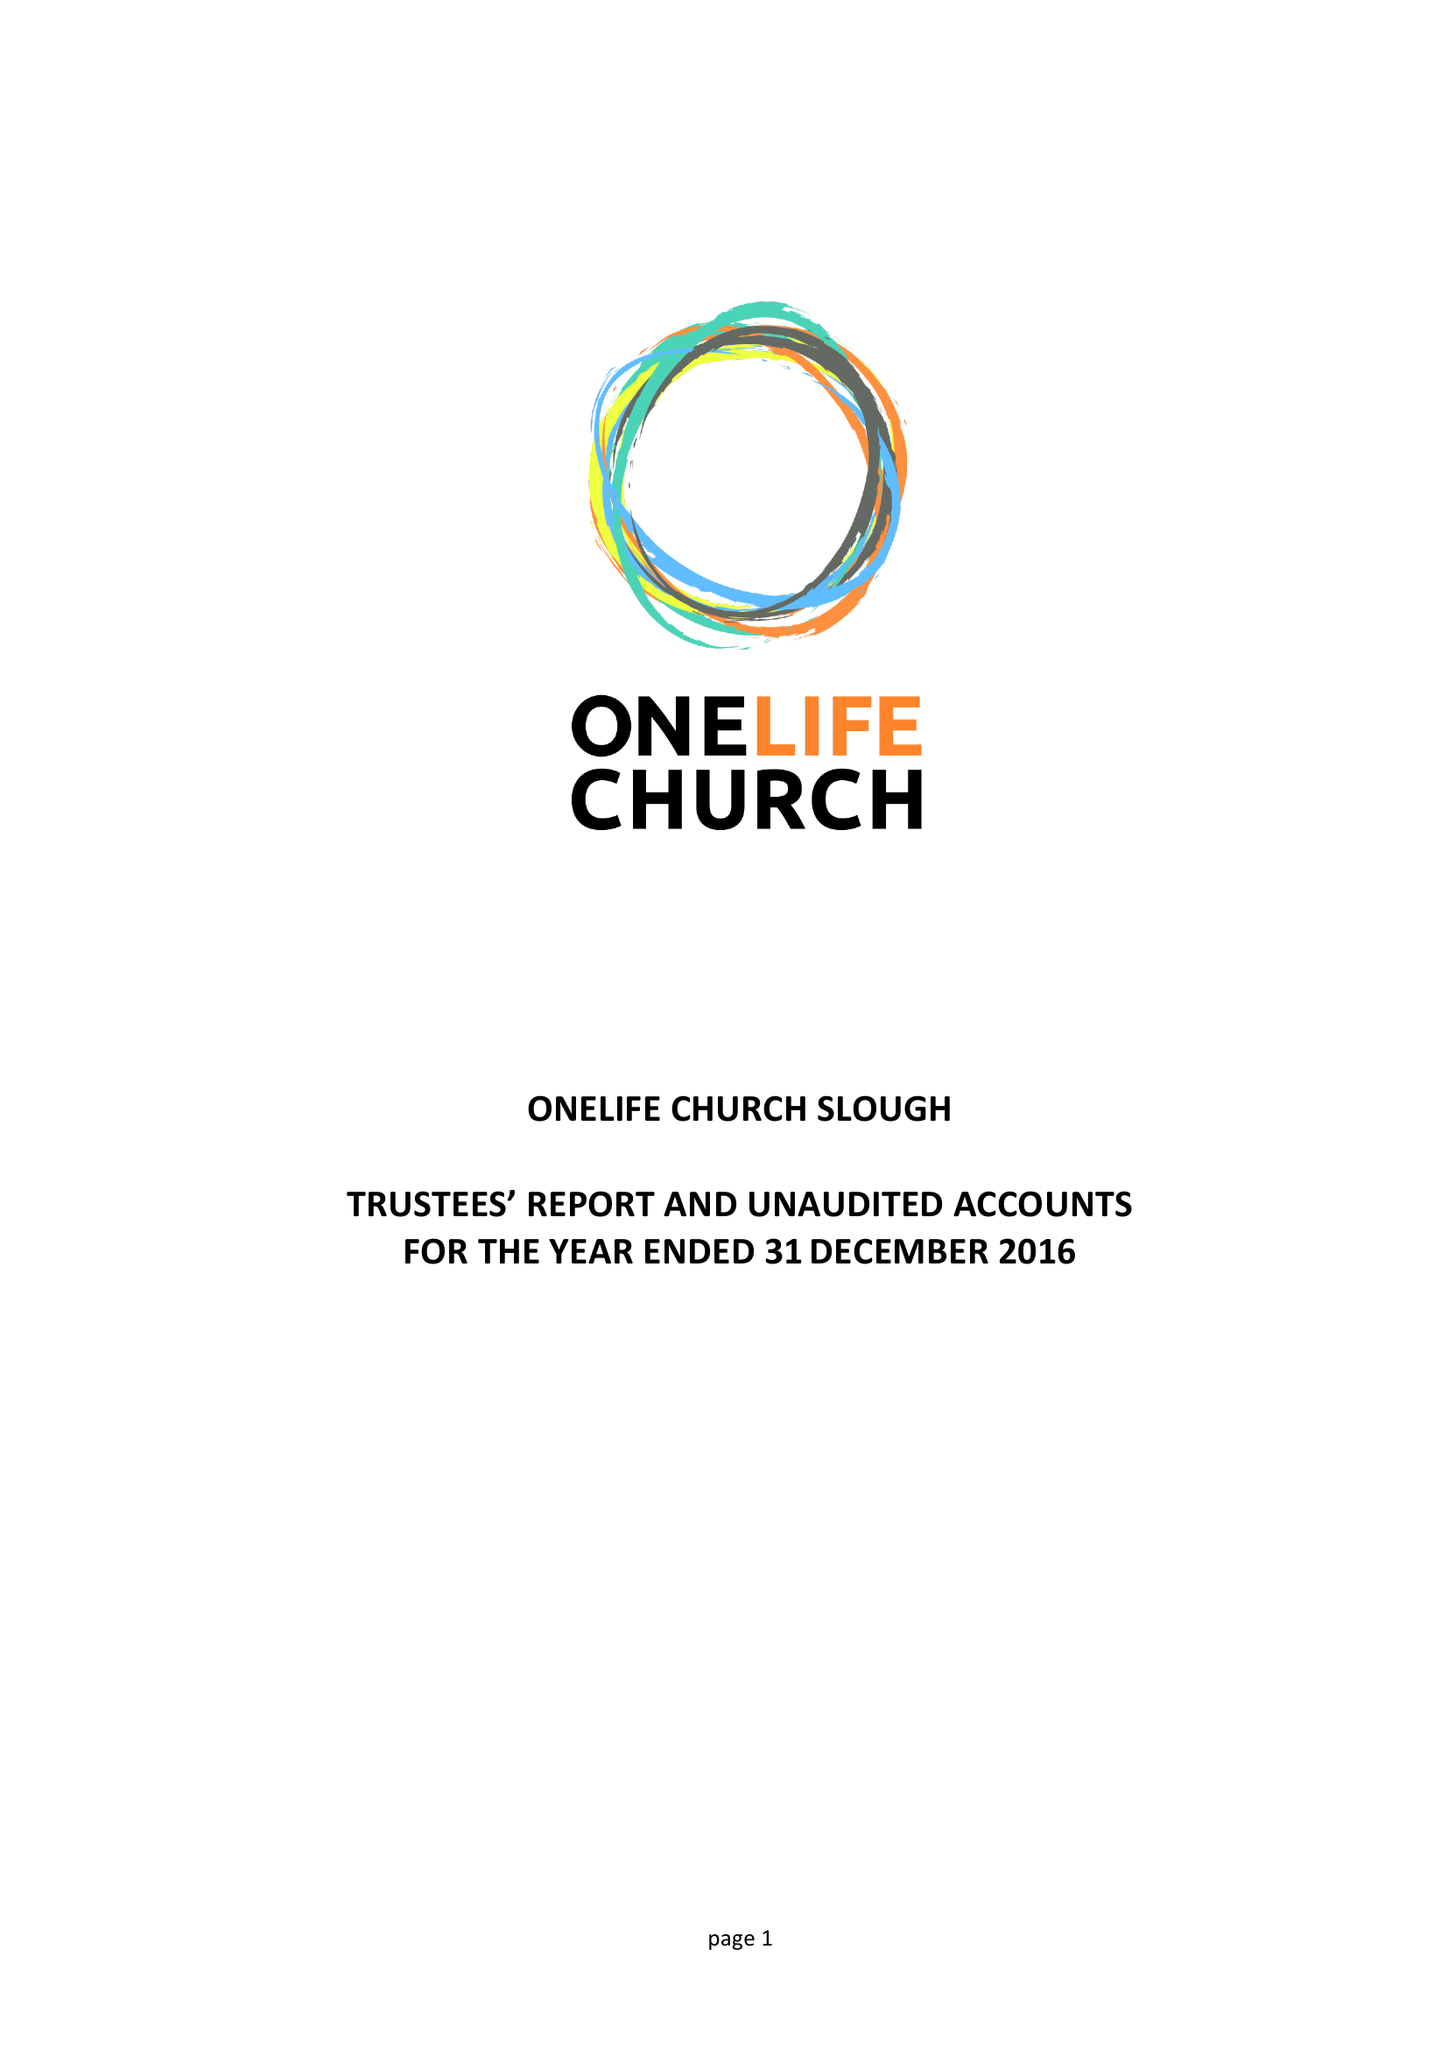What is the value for the income_annually_in_british_pounds?
Answer the question using a single word or phrase. 31851.00 